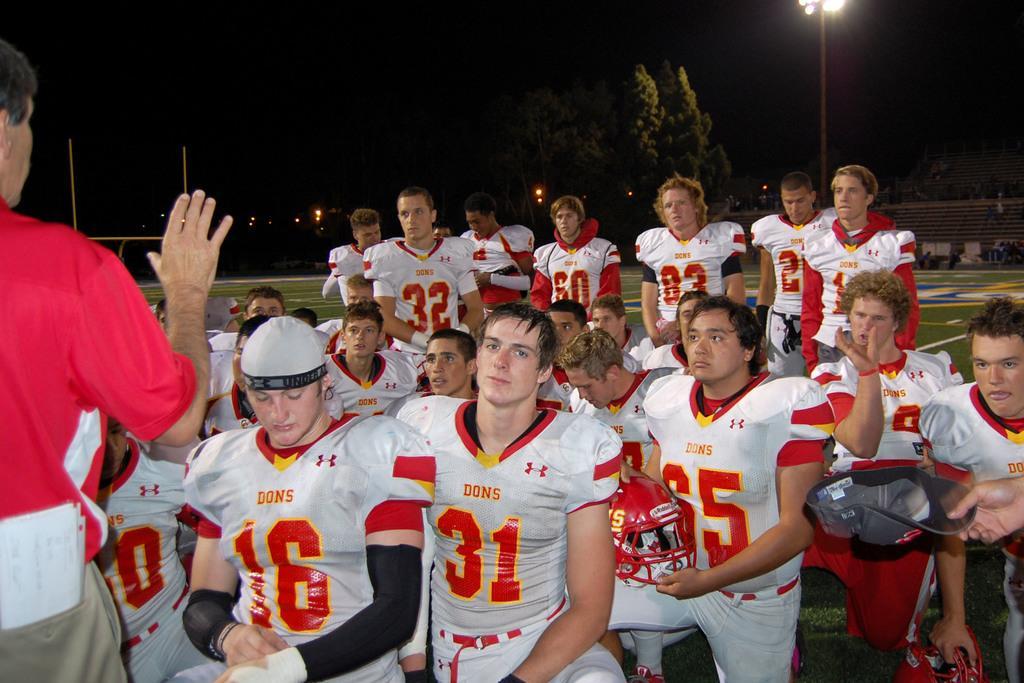In one or two sentences, can you explain what this image depicts? In this image there are so many rugby players who are sitting and listening to the man who is speaking in front of them. In the background there are trees and flood light. In the middle there is a rugby player who is sitting by holding the helmet. 